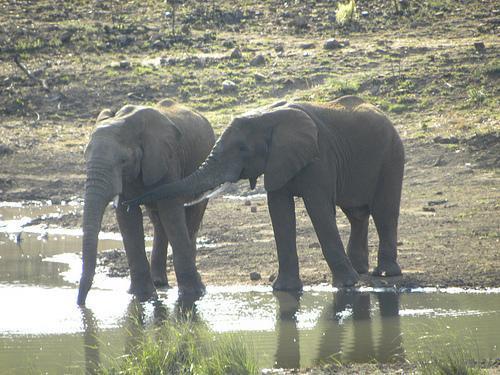How many elephants are in the photo?
Give a very brief answer. 2. How many legs are in the photo?
Give a very brief answer. 8. How many elephants can you see just one tusk on?
Give a very brief answer. 1. 